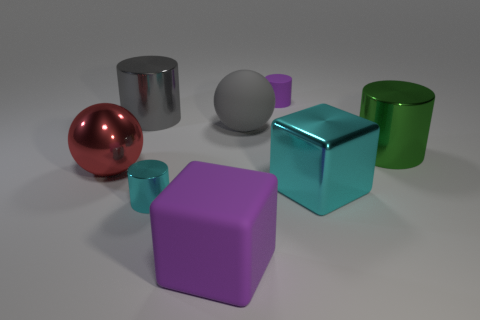Subtract all cyan metal cylinders. How many cylinders are left? 3 Subtract all cyan cylinders. How many cylinders are left? 3 Add 1 cyan balls. How many objects exist? 9 Subtract all yellow cylinders. Subtract all green blocks. How many cylinders are left? 4 Subtract all cubes. How many objects are left? 6 Subtract all small gray metallic objects. Subtract all green shiny cylinders. How many objects are left? 7 Add 4 metal cylinders. How many metal cylinders are left? 7 Add 5 big purple matte objects. How many big purple matte objects exist? 6 Subtract 1 purple cylinders. How many objects are left? 7 